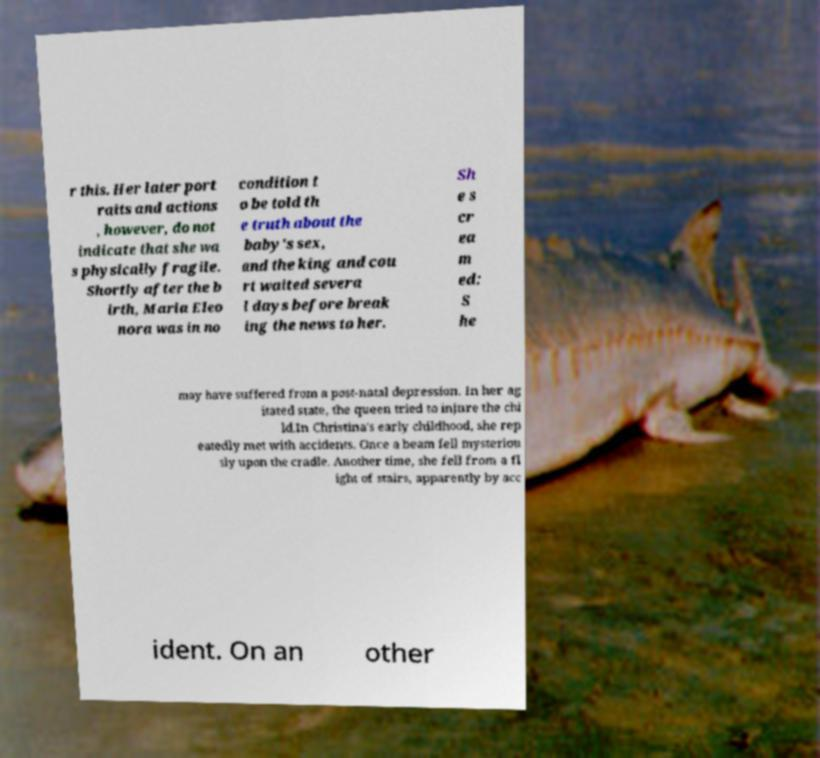Could you assist in decoding the text presented in this image and type it out clearly? r this. Her later port raits and actions , however, do not indicate that she wa s physically fragile. Shortly after the b irth, Maria Eleo nora was in no condition t o be told th e truth about the baby's sex, and the king and cou rt waited severa l days before break ing the news to her. Sh e s cr ea m ed: S he may have suffered from a post-natal depression. In her ag itated state, the queen tried to injure the chi ld.In Christina's early childhood, she rep eatedly met with accidents. Once a beam fell mysteriou sly upon the cradle. Another time, she fell from a fl ight of stairs, apparently by acc ident. On an other 